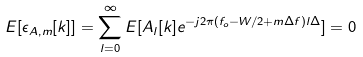<formula> <loc_0><loc_0><loc_500><loc_500>E [ \epsilon _ { A , m } [ k ] ] = \sum _ { l = 0 } ^ { \infty } E [ A _ { l } [ k ] e ^ { - j 2 \pi ( f _ { o } - W / 2 + m \Delta f ) l \Delta } ] = 0</formula> 